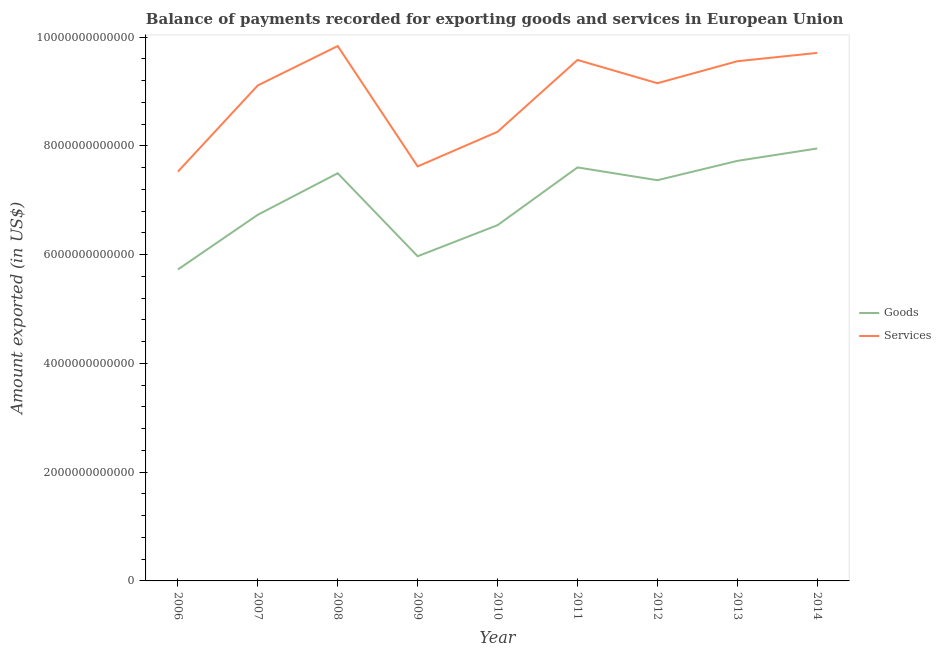Does the line corresponding to amount of goods exported intersect with the line corresponding to amount of services exported?
Your answer should be very brief. No. What is the amount of goods exported in 2008?
Keep it short and to the point. 7.50e+12. Across all years, what is the maximum amount of services exported?
Offer a terse response. 9.84e+12. Across all years, what is the minimum amount of goods exported?
Your answer should be very brief. 5.73e+12. In which year was the amount of goods exported minimum?
Your answer should be very brief. 2006. What is the total amount of goods exported in the graph?
Your answer should be very brief. 6.31e+13. What is the difference between the amount of goods exported in 2008 and that in 2012?
Provide a succinct answer. 1.28e+11. What is the difference between the amount of services exported in 2013 and the amount of goods exported in 2011?
Provide a succinct answer. 1.95e+12. What is the average amount of goods exported per year?
Ensure brevity in your answer.  7.01e+12. In the year 2011, what is the difference between the amount of services exported and amount of goods exported?
Keep it short and to the point. 1.98e+12. In how many years, is the amount of goods exported greater than 6400000000000 US$?
Provide a succinct answer. 7. What is the ratio of the amount of services exported in 2012 to that in 2013?
Provide a succinct answer. 0.96. What is the difference between the highest and the second highest amount of services exported?
Provide a short and direct response. 1.26e+11. What is the difference between the highest and the lowest amount of services exported?
Make the answer very short. 2.31e+12. In how many years, is the amount of goods exported greater than the average amount of goods exported taken over all years?
Make the answer very short. 5. Is the amount of goods exported strictly greater than the amount of services exported over the years?
Your answer should be compact. No. How many years are there in the graph?
Offer a very short reply. 9. What is the difference between two consecutive major ticks on the Y-axis?
Offer a very short reply. 2.00e+12. Are the values on the major ticks of Y-axis written in scientific E-notation?
Provide a short and direct response. No. Does the graph contain any zero values?
Your answer should be very brief. No. Does the graph contain grids?
Provide a short and direct response. No. Where does the legend appear in the graph?
Offer a very short reply. Center right. What is the title of the graph?
Your response must be concise. Balance of payments recorded for exporting goods and services in European Union. What is the label or title of the Y-axis?
Make the answer very short. Amount exported (in US$). What is the Amount exported (in US$) in Goods in 2006?
Make the answer very short. 5.73e+12. What is the Amount exported (in US$) of Services in 2006?
Your answer should be very brief. 7.53e+12. What is the Amount exported (in US$) of Goods in 2007?
Offer a very short reply. 6.73e+12. What is the Amount exported (in US$) of Services in 2007?
Give a very brief answer. 9.11e+12. What is the Amount exported (in US$) in Goods in 2008?
Provide a succinct answer. 7.50e+12. What is the Amount exported (in US$) of Services in 2008?
Provide a succinct answer. 9.84e+12. What is the Amount exported (in US$) in Goods in 2009?
Ensure brevity in your answer.  5.97e+12. What is the Amount exported (in US$) of Services in 2009?
Provide a succinct answer. 7.62e+12. What is the Amount exported (in US$) in Goods in 2010?
Offer a very short reply. 6.54e+12. What is the Amount exported (in US$) in Services in 2010?
Ensure brevity in your answer.  8.26e+12. What is the Amount exported (in US$) in Goods in 2011?
Offer a terse response. 7.60e+12. What is the Amount exported (in US$) of Services in 2011?
Your answer should be very brief. 9.58e+12. What is the Amount exported (in US$) of Goods in 2012?
Offer a terse response. 7.37e+12. What is the Amount exported (in US$) of Services in 2012?
Your response must be concise. 9.15e+12. What is the Amount exported (in US$) in Goods in 2013?
Offer a terse response. 7.72e+12. What is the Amount exported (in US$) in Services in 2013?
Ensure brevity in your answer.  9.56e+12. What is the Amount exported (in US$) in Goods in 2014?
Ensure brevity in your answer.  7.95e+12. What is the Amount exported (in US$) in Services in 2014?
Your response must be concise. 9.71e+12. Across all years, what is the maximum Amount exported (in US$) of Goods?
Provide a short and direct response. 7.95e+12. Across all years, what is the maximum Amount exported (in US$) in Services?
Offer a very short reply. 9.84e+12. Across all years, what is the minimum Amount exported (in US$) of Goods?
Keep it short and to the point. 5.73e+12. Across all years, what is the minimum Amount exported (in US$) of Services?
Your response must be concise. 7.53e+12. What is the total Amount exported (in US$) in Goods in the graph?
Your answer should be very brief. 6.31e+13. What is the total Amount exported (in US$) in Services in the graph?
Make the answer very short. 8.03e+13. What is the difference between the Amount exported (in US$) of Goods in 2006 and that in 2007?
Offer a very short reply. -1.01e+12. What is the difference between the Amount exported (in US$) of Services in 2006 and that in 2007?
Ensure brevity in your answer.  -1.59e+12. What is the difference between the Amount exported (in US$) of Goods in 2006 and that in 2008?
Keep it short and to the point. -1.77e+12. What is the difference between the Amount exported (in US$) of Services in 2006 and that in 2008?
Keep it short and to the point. -2.31e+12. What is the difference between the Amount exported (in US$) in Goods in 2006 and that in 2009?
Your response must be concise. -2.44e+11. What is the difference between the Amount exported (in US$) in Services in 2006 and that in 2009?
Ensure brevity in your answer.  -9.64e+1. What is the difference between the Amount exported (in US$) of Goods in 2006 and that in 2010?
Offer a terse response. -8.15e+11. What is the difference between the Amount exported (in US$) in Services in 2006 and that in 2010?
Provide a short and direct response. -7.33e+11. What is the difference between the Amount exported (in US$) in Goods in 2006 and that in 2011?
Make the answer very short. -1.88e+12. What is the difference between the Amount exported (in US$) in Services in 2006 and that in 2011?
Provide a short and direct response. -2.05e+12. What is the difference between the Amount exported (in US$) of Goods in 2006 and that in 2012?
Your response must be concise. -1.64e+12. What is the difference between the Amount exported (in US$) of Services in 2006 and that in 2012?
Give a very brief answer. -1.63e+12. What is the difference between the Amount exported (in US$) of Goods in 2006 and that in 2013?
Your answer should be very brief. -2.00e+12. What is the difference between the Amount exported (in US$) in Services in 2006 and that in 2013?
Offer a very short reply. -2.03e+12. What is the difference between the Amount exported (in US$) in Goods in 2006 and that in 2014?
Keep it short and to the point. -2.23e+12. What is the difference between the Amount exported (in US$) in Services in 2006 and that in 2014?
Make the answer very short. -2.18e+12. What is the difference between the Amount exported (in US$) in Goods in 2007 and that in 2008?
Give a very brief answer. -7.64e+11. What is the difference between the Amount exported (in US$) in Services in 2007 and that in 2008?
Your answer should be compact. -7.24e+11. What is the difference between the Amount exported (in US$) of Goods in 2007 and that in 2009?
Offer a terse response. 7.62e+11. What is the difference between the Amount exported (in US$) of Services in 2007 and that in 2009?
Your response must be concise. 1.49e+12. What is the difference between the Amount exported (in US$) in Goods in 2007 and that in 2010?
Your answer should be compact. 1.91e+11. What is the difference between the Amount exported (in US$) of Services in 2007 and that in 2010?
Your answer should be compact. 8.53e+11. What is the difference between the Amount exported (in US$) in Goods in 2007 and that in 2011?
Ensure brevity in your answer.  -8.71e+11. What is the difference between the Amount exported (in US$) of Services in 2007 and that in 2011?
Give a very brief answer. -4.68e+11. What is the difference between the Amount exported (in US$) in Goods in 2007 and that in 2012?
Give a very brief answer. -6.36e+11. What is the difference between the Amount exported (in US$) of Services in 2007 and that in 2012?
Offer a very short reply. -4.03e+1. What is the difference between the Amount exported (in US$) of Goods in 2007 and that in 2013?
Provide a short and direct response. -9.91e+11. What is the difference between the Amount exported (in US$) of Services in 2007 and that in 2013?
Offer a very short reply. -4.45e+11. What is the difference between the Amount exported (in US$) of Goods in 2007 and that in 2014?
Offer a terse response. -1.22e+12. What is the difference between the Amount exported (in US$) in Services in 2007 and that in 2014?
Your response must be concise. -5.98e+11. What is the difference between the Amount exported (in US$) of Goods in 2008 and that in 2009?
Provide a short and direct response. 1.53e+12. What is the difference between the Amount exported (in US$) of Services in 2008 and that in 2009?
Offer a very short reply. 2.21e+12. What is the difference between the Amount exported (in US$) in Goods in 2008 and that in 2010?
Your answer should be very brief. 9.54e+11. What is the difference between the Amount exported (in US$) of Services in 2008 and that in 2010?
Ensure brevity in your answer.  1.58e+12. What is the difference between the Amount exported (in US$) in Goods in 2008 and that in 2011?
Give a very brief answer. -1.07e+11. What is the difference between the Amount exported (in US$) in Services in 2008 and that in 2011?
Give a very brief answer. 2.56e+11. What is the difference between the Amount exported (in US$) of Goods in 2008 and that in 2012?
Your response must be concise. 1.28e+11. What is the difference between the Amount exported (in US$) of Services in 2008 and that in 2012?
Provide a succinct answer. 6.83e+11. What is the difference between the Amount exported (in US$) in Goods in 2008 and that in 2013?
Keep it short and to the point. -2.27e+11. What is the difference between the Amount exported (in US$) in Services in 2008 and that in 2013?
Your answer should be very brief. 2.79e+11. What is the difference between the Amount exported (in US$) in Goods in 2008 and that in 2014?
Give a very brief answer. -4.56e+11. What is the difference between the Amount exported (in US$) of Services in 2008 and that in 2014?
Your answer should be compact. 1.26e+11. What is the difference between the Amount exported (in US$) of Goods in 2009 and that in 2010?
Offer a terse response. -5.71e+11. What is the difference between the Amount exported (in US$) in Services in 2009 and that in 2010?
Offer a very short reply. -6.37e+11. What is the difference between the Amount exported (in US$) of Goods in 2009 and that in 2011?
Offer a terse response. -1.63e+12. What is the difference between the Amount exported (in US$) of Services in 2009 and that in 2011?
Ensure brevity in your answer.  -1.96e+12. What is the difference between the Amount exported (in US$) of Goods in 2009 and that in 2012?
Ensure brevity in your answer.  -1.40e+12. What is the difference between the Amount exported (in US$) of Services in 2009 and that in 2012?
Your answer should be very brief. -1.53e+12. What is the difference between the Amount exported (in US$) in Goods in 2009 and that in 2013?
Ensure brevity in your answer.  -1.75e+12. What is the difference between the Amount exported (in US$) in Services in 2009 and that in 2013?
Give a very brief answer. -1.93e+12. What is the difference between the Amount exported (in US$) in Goods in 2009 and that in 2014?
Offer a terse response. -1.98e+12. What is the difference between the Amount exported (in US$) in Services in 2009 and that in 2014?
Offer a very short reply. -2.09e+12. What is the difference between the Amount exported (in US$) of Goods in 2010 and that in 2011?
Your answer should be very brief. -1.06e+12. What is the difference between the Amount exported (in US$) in Services in 2010 and that in 2011?
Make the answer very short. -1.32e+12. What is the difference between the Amount exported (in US$) in Goods in 2010 and that in 2012?
Provide a short and direct response. -8.27e+11. What is the difference between the Amount exported (in US$) of Services in 2010 and that in 2012?
Offer a very short reply. -8.93e+11. What is the difference between the Amount exported (in US$) in Goods in 2010 and that in 2013?
Keep it short and to the point. -1.18e+12. What is the difference between the Amount exported (in US$) in Services in 2010 and that in 2013?
Offer a very short reply. -1.30e+12. What is the difference between the Amount exported (in US$) in Goods in 2010 and that in 2014?
Offer a terse response. -1.41e+12. What is the difference between the Amount exported (in US$) in Services in 2010 and that in 2014?
Offer a terse response. -1.45e+12. What is the difference between the Amount exported (in US$) in Goods in 2011 and that in 2012?
Provide a succinct answer. 2.35e+11. What is the difference between the Amount exported (in US$) of Services in 2011 and that in 2012?
Your answer should be compact. 4.28e+11. What is the difference between the Amount exported (in US$) of Goods in 2011 and that in 2013?
Your response must be concise. -1.20e+11. What is the difference between the Amount exported (in US$) in Services in 2011 and that in 2013?
Provide a succinct answer. 2.33e+1. What is the difference between the Amount exported (in US$) in Goods in 2011 and that in 2014?
Your answer should be compact. -3.49e+11. What is the difference between the Amount exported (in US$) of Services in 2011 and that in 2014?
Provide a short and direct response. -1.30e+11. What is the difference between the Amount exported (in US$) of Goods in 2012 and that in 2013?
Your answer should be compact. -3.55e+11. What is the difference between the Amount exported (in US$) of Services in 2012 and that in 2013?
Offer a very short reply. -4.04e+11. What is the difference between the Amount exported (in US$) of Goods in 2012 and that in 2014?
Offer a very short reply. -5.84e+11. What is the difference between the Amount exported (in US$) of Services in 2012 and that in 2014?
Give a very brief answer. -5.58e+11. What is the difference between the Amount exported (in US$) in Goods in 2013 and that in 2014?
Give a very brief answer. -2.28e+11. What is the difference between the Amount exported (in US$) in Services in 2013 and that in 2014?
Provide a succinct answer. -1.54e+11. What is the difference between the Amount exported (in US$) of Goods in 2006 and the Amount exported (in US$) of Services in 2007?
Your answer should be compact. -3.39e+12. What is the difference between the Amount exported (in US$) in Goods in 2006 and the Amount exported (in US$) in Services in 2008?
Offer a very short reply. -4.11e+12. What is the difference between the Amount exported (in US$) in Goods in 2006 and the Amount exported (in US$) in Services in 2009?
Your answer should be compact. -1.90e+12. What is the difference between the Amount exported (in US$) of Goods in 2006 and the Amount exported (in US$) of Services in 2010?
Offer a terse response. -2.53e+12. What is the difference between the Amount exported (in US$) in Goods in 2006 and the Amount exported (in US$) in Services in 2011?
Keep it short and to the point. -3.85e+12. What is the difference between the Amount exported (in US$) in Goods in 2006 and the Amount exported (in US$) in Services in 2012?
Provide a succinct answer. -3.43e+12. What is the difference between the Amount exported (in US$) of Goods in 2006 and the Amount exported (in US$) of Services in 2013?
Your response must be concise. -3.83e+12. What is the difference between the Amount exported (in US$) of Goods in 2006 and the Amount exported (in US$) of Services in 2014?
Your response must be concise. -3.98e+12. What is the difference between the Amount exported (in US$) of Goods in 2007 and the Amount exported (in US$) of Services in 2008?
Make the answer very short. -3.10e+12. What is the difference between the Amount exported (in US$) of Goods in 2007 and the Amount exported (in US$) of Services in 2009?
Make the answer very short. -8.89e+11. What is the difference between the Amount exported (in US$) in Goods in 2007 and the Amount exported (in US$) in Services in 2010?
Offer a very short reply. -1.53e+12. What is the difference between the Amount exported (in US$) in Goods in 2007 and the Amount exported (in US$) in Services in 2011?
Make the answer very short. -2.85e+12. What is the difference between the Amount exported (in US$) of Goods in 2007 and the Amount exported (in US$) of Services in 2012?
Offer a terse response. -2.42e+12. What is the difference between the Amount exported (in US$) of Goods in 2007 and the Amount exported (in US$) of Services in 2013?
Make the answer very short. -2.82e+12. What is the difference between the Amount exported (in US$) in Goods in 2007 and the Amount exported (in US$) in Services in 2014?
Keep it short and to the point. -2.98e+12. What is the difference between the Amount exported (in US$) of Goods in 2008 and the Amount exported (in US$) of Services in 2009?
Your answer should be very brief. -1.26e+11. What is the difference between the Amount exported (in US$) of Goods in 2008 and the Amount exported (in US$) of Services in 2010?
Your answer should be compact. -7.63e+11. What is the difference between the Amount exported (in US$) in Goods in 2008 and the Amount exported (in US$) in Services in 2011?
Keep it short and to the point. -2.08e+12. What is the difference between the Amount exported (in US$) in Goods in 2008 and the Amount exported (in US$) in Services in 2012?
Ensure brevity in your answer.  -1.66e+12. What is the difference between the Amount exported (in US$) in Goods in 2008 and the Amount exported (in US$) in Services in 2013?
Give a very brief answer. -2.06e+12. What is the difference between the Amount exported (in US$) of Goods in 2008 and the Amount exported (in US$) of Services in 2014?
Keep it short and to the point. -2.21e+12. What is the difference between the Amount exported (in US$) in Goods in 2009 and the Amount exported (in US$) in Services in 2010?
Your answer should be very brief. -2.29e+12. What is the difference between the Amount exported (in US$) of Goods in 2009 and the Amount exported (in US$) of Services in 2011?
Keep it short and to the point. -3.61e+12. What is the difference between the Amount exported (in US$) in Goods in 2009 and the Amount exported (in US$) in Services in 2012?
Provide a short and direct response. -3.18e+12. What is the difference between the Amount exported (in US$) of Goods in 2009 and the Amount exported (in US$) of Services in 2013?
Provide a succinct answer. -3.59e+12. What is the difference between the Amount exported (in US$) in Goods in 2009 and the Amount exported (in US$) in Services in 2014?
Offer a very short reply. -3.74e+12. What is the difference between the Amount exported (in US$) in Goods in 2010 and the Amount exported (in US$) in Services in 2011?
Make the answer very short. -3.04e+12. What is the difference between the Amount exported (in US$) in Goods in 2010 and the Amount exported (in US$) in Services in 2012?
Your answer should be compact. -2.61e+12. What is the difference between the Amount exported (in US$) of Goods in 2010 and the Amount exported (in US$) of Services in 2013?
Keep it short and to the point. -3.01e+12. What is the difference between the Amount exported (in US$) of Goods in 2010 and the Amount exported (in US$) of Services in 2014?
Ensure brevity in your answer.  -3.17e+12. What is the difference between the Amount exported (in US$) in Goods in 2011 and the Amount exported (in US$) in Services in 2012?
Give a very brief answer. -1.55e+12. What is the difference between the Amount exported (in US$) in Goods in 2011 and the Amount exported (in US$) in Services in 2013?
Your answer should be compact. -1.95e+12. What is the difference between the Amount exported (in US$) of Goods in 2011 and the Amount exported (in US$) of Services in 2014?
Keep it short and to the point. -2.11e+12. What is the difference between the Amount exported (in US$) of Goods in 2012 and the Amount exported (in US$) of Services in 2013?
Provide a succinct answer. -2.19e+12. What is the difference between the Amount exported (in US$) in Goods in 2012 and the Amount exported (in US$) in Services in 2014?
Provide a short and direct response. -2.34e+12. What is the difference between the Amount exported (in US$) of Goods in 2013 and the Amount exported (in US$) of Services in 2014?
Ensure brevity in your answer.  -1.99e+12. What is the average Amount exported (in US$) of Goods per year?
Provide a short and direct response. 7.01e+12. What is the average Amount exported (in US$) of Services per year?
Your answer should be very brief. 8.93e+12. In the year 2006, what is the difference between the Amount exported (in US$) of Goods and Amount exported (in US$) of Services?
Your response must be concise. -1.80e+12. In the year 2007, what is the difference between the Amount exported (in US$) of Goods and Amount exported (in US$) of Services?
Offer a terse response. -2.38e+12. In the year 2008, what is the difference between the Amount exported (in US$) in Goods and Amount exported (in US$) in Services?
Provide a succinct answer. -2.34e+12. In the year 2009, what is the difference between the Amount exported (in US$) of Goods and Amount exported (in US$) of Services?
Make the answer very short. -1.65e+12. In the year 2010, what is the difference between the Amount exported (in US$) of Goods and Amount exported (in US$) of Services?
Give a very brief answer. -1.72e+12. In the year 2011, what is the difference between the Amount exported (in US$) in Goods and Amount exported (in US$) in Services?
Give a very brief answer. -1.98e+12. In the year 2012, what is the difference between the Amount exported (in US$) in Goods and Amount exported (in US$) in Services?
Your answer should be very brief. -1.78e+12. In the year 2013, what is the difference between the Amount exported (in US$) in Goods and Amount exported (in US$) in Services?
Give a very brief answer. -1.83e+12. In the year 2014, what is the difference between the Amount exported (in US$) of Goods and Amount exported (in US$) of Services?
Your answer should be very brief. -1.76e+12. What is the ratio of the Amount exported (in US$) in Goods in 2006 to that in 2007?
Ensure brevity in your answer.  0.85. What is the ratio of the Amount exported (in US$) in Services in 2006 to that in 2007?
Give a very brief answer. 0.83. What is the ratio of the Amount exported (in US$) of Goods in 2006 to that in 2008?
Your answer should be compact. 0.76. What is the ratio of the Amount exported (in US$) in Services in 2006 to that in 2008?
Your answer should be very brief. 0.77. What is the ratio of the Amount exported (in US$) of Goods in 2006 to that in 2009?
Provide a short and direct response. 0.96. What is the ratio of the Amount exported (in US$) of Services in 2006 to that in 2009?
Offer a terse response. 0.99. What is the ratio of the Amount exported (in US$) in Goods in 2006 to that in 2010?
Make the answer very short. 0.88. What is the ratio of the Amount exported (in US$) of Services in 2006 to that in 2010?
Give a very brief answer. 0.91. What is the ratio of the Amount exported (in US$) in Goods in 2006 to that in 2011?
Give a very brief answer. 0.75. What is the ratio of the Amount exported (in US$) of Services in 2006 to that in 2011?
Provide a succinct answer. 0.79. What is the ratio of the Amount exported (in US$) in Goods in 2006 to that in 2012?
Keep it short and to the point. 0.78. What is the ratio of the Amount exported (in US$) of Services in 2006 to that in 2012?
Provide a succinct answer. 0.82. What is the ratio of the Amount exported (in US$) of Goods in 2006 to that in 2013?
Your answer should be compact. 0.74. What is the ratio of the Amount exported (in US$) of Services in 2006 to that in 2013?
Your answer should be compact. 0.79. What is the ratio of the Amount exported (in US$) in Goods in 2006 to that in 2014?
Make the answer very short. 0.72. What is the ratio of the Amount exported (in US$) in Services in 2006 to that in 2014?
Give a very brief answer. 0.78. What is the ratio of the Amount exported (in US$) of Goods in 2007 to that in 2008?
Provide a short and direct response. 0.9. What is the ratio of the Amount exported (in US$) in Services in 2007 to that in 2008?
Offer a very short reply. 0.93. What is the ratio of the Amount exported (in US$) in Goods in 2007 to that in 2009?
Provide a succinct answer. 1.13. What is the ratio of the Amount exported (in US$) of Services in 2007 to that in 2009?
Provide a short and direct response. 1.2. What is the ratio of the Amount exported (in US$) in Goods in 2007 to that in 2010?
Offer a terse response. 1.03. What is the ratio of the Amount exported (in US$) in Services in 2007 to that in 2010?
Your answer should be compact. 1.1. What is the ratio of the Amount exported (in US$) in Goods in 2007 to that in 2011?
Give a very brief answer. 0.89. What is the ratio of the Amount exported (in US$) of Services in 2007 to that in 2011?
Make the answer very short. 0.95. What is the ratio of the Amount exported (in US$) of Goods in 2007 to that in 2012?
Ensure brevity in your answer.  0.91. What is the ratio of the Amount exported (in US$) in Services in 2007 to that in 2012?
Your answer should be compact. 1. What is the ratio of the Amount exported (in US$) in Goods in 2007 to that in 2013?
Make the answer very short. 0.87. What is the ratio of the Amount exported (in US$) of Services in 2007 to that in 2013?
Give a very brief answer. 0.95. What is the ratio of the Amount exported (in US$) in Goods in 2007 to that in 2014?
Keep it short and to the point. 0.85. What is the ratio of the Amount exported (in US$) of Services in 2007 to that in 2014?
Provide a short and direct response. 0.94. What is the ratio of the Amount exported (in US$) in Goods in 2008 to that in 2009?
Your answer should be compact. 1.26. What is the ratio of the Amount exported (in US$) of Services in 2008 to that in 2009?
Your response must be concise. 1.29. What is the ratio of the Amount exported (in US$) of Goods in 2008 to that in 2010?
Ensure brevity in your answer.  1.15. What is the ratio of the Amount exported (in US$) of Services in 2008 to that in 2010?
Your answer should be very brief. 1.19. What is the ratio of the Amount exported (in US$) of Goods in 2008 to that in 2011?
Make the answer very short. 0.99. What is the ratio of the Amount exported (in US$) in Services in 2008 to that in 2011?
Provide a short and direct response. 1.03. What is the ratio of the Amount exported (in US$) in Goods in 2008 to that in 2012?
Your answer should be compact. 1.02. What is the ratio of the Amount exported (in US$) of Services in 2008 to that in 2012?
Offer a terse response. 1.07. What is the ratio of the Amount exported (in US$) of Goods in 2008 to that in 2013?
Offer a terse response. 0.97. What is the ratio of the Amount exported (in US$) of Services in 2008 to that in 2013?
Your answer should be very brief. 1.03. What is the ratio of the Amount exported (in US$) of Goods in 2008 to that in 2014?
Ensure brevity in your answer.  0.94. What is the ratio of the Amount exported (in US$) of Services in 2008 to that in 2014?
Your answer should be very brief. 1.01. What is the ratio of the Amount exported (in US$) of Goods in 2009 to that in 2010?
Give a very brief answer. 0.91. What is the ratio of the Amount exported (in US$) of Services in 2009 to that in 2010?
Keep it short and to the point. 0.92. What is the ratio of the Amount exported (in US$) of Goods in 2009 to that in 2011?
Your answer should be very brief. 0.79. What is the ratio of the Amount exported (in US$) in Services in 2009 to that in 2011?
Give a very brief answer. 0.8. What is the ratio of the Amount exported (in US$) in Goods in 2009 to that in 2012?
Provide a succinct answer. 0.81. What is the ratio of the Amount exported (in US$) of Services in 2009 to that in 2012?
Make the answer very short. 0.83. What is the ratio of the Amount exported (in US$) of Goods in 2009 to that in 2013?
Make the answer very short. 0.77. What is the ratio of the Amount exported (in US$) of Services in 2009 to that in 2013?
Your answer should be compact. 0.8. What is the ratio of the Amount exported (in US$) of Goods in 2009 to that in 2014?
Give a very brief answer. 0.75. What is the ratio of the Amount exported (in US$) in Services in 2009 to that in 2014?
Your response must be concise. 0.79. What is the ratio of the Amount exported (in US$) in Goods in 2010 to that in 2011?
Make the answer very short. 0.86. What is the ratio of the Amount exported (in US$) in Services in 2010 to that in 2011?
Provide a short and direct response. 0.86. What is the ratio of the Amount exported (in US$) of Goods in 2010 to that in 2012?
Provide a short and direct response. 0.89. What is the ratio of the Amount exported (in US$) in Services in 2010 to that in 2012?
Provide a succinct answer. 0.9. What is the ratio of the Amount exported (in US$) in Goods in 2010 to that in 2013?
Your answer should be compact. 0.85. What is the ratio of the Amount exported (in US$) of Services in 2010 to that in 2013?
Offer a very short reply. 0.86. What is the ratio of the Amount exported (in US$) in Goods in 2010 to that in 2014?
Provide a short and direct response. 0.82. What is the ratio of the Amount exported (in US$) in Services in 2010 to that in 2014?
Offer a terse response. 0.85. What is the ratio of the Amount exported (in US$) of Goods in 2011 to that in 2012?
Your answer should be compact. 1.03. What is the ratio of the Amount exported (in US$) in Services in 2011 to that in 2012?
Offer a terse response. 1.05. What is the ratio of the Amount exported (in US$) in Goods in 2011 to that in 2013?
Offer a terse response. 0.98. What is the ratio of the Amount exported (in US$) of Goods in 2011 to that in 2014?
Make the answer very short. 0.96. What is the ratio of the Amount exported (in US$) in Services in 2011 to that in 2014?
Make the answer very short. 0.99. What is the ratio of the Amount exported (in US$) of Goods in 2012 to that in 2013?
Make the answer very short. 0.95. What is the ratio of the Amount exported (in US$) in Services in 2012 to that in 2013?
Your answer should be very brief. 0.96. What is the ratio of the Amount exported (in US$) of Goods in 2012 to that in 2014?
Make the answer very short. 0.93. What is the ratio of the Amount exported (in US$) of Services in 2012 to that in 2014?
Your answer should be very brief. 0.94. What is the ratio of the Amount exported (in US$) in Goods in 2013 to that in 2014?
Ensure brevity in your answer.  0.97. What is the ratio of the Amount exported (in US$) of Services in 2013 to that in 2014?
Give a very brief answer. 0.98. What is the difference between the highest and the second highest Amount exported (in US$) of Goods?
Make the answer very short. 2.28e+11. What is the difference between the highest and the second highest Amount exported (in US$) of Services?
Give a very brief answer. 1.26e+11. What is the difference between the highest and the lowest Amount exported (in US$) in Goods?
Provide a succinct answer. 2.23e+12. What is the difference between the highest and the lowest Amount exported (in US$) of Services?
Offer a very short reply. 2.31e+12. 